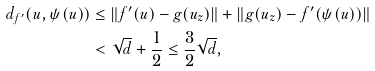Convert formula to latex. <formula><loc_0><loc_0><loc_500><loc_500>d _ { f ^ { \prime } } ( u , \psi ( u ) ) & \leq \| f ^ { \prime } ( u ) - g ( u _ { z } ) \| + \| g ( u _ { z } ) - f ^ { \prime } ( \psi ( u ) ) \| \\ & < \sqrt { d } + \frac { 1 } { 2 } \leq \frac { 3 } { 2 } \sqrt { d } ,</formula> 